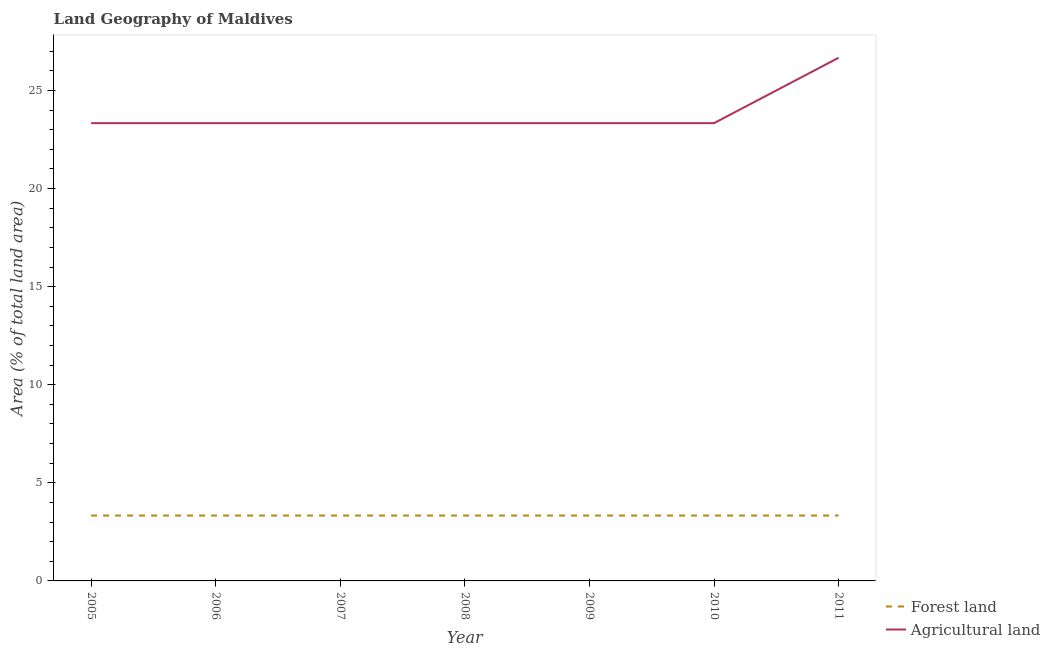How many different coloured lines are there?
Your answer should be compact. 2. Does the line corresponding to percentage of land area under forests intersect with the line corresponding to percentage of land area under agriculture?
Provide a short and direct response. No. What is the percentage of land area under forests in 2005?
Ensure brevity in your answer.  3.33. Across all years, what is the maximum percentage of land area under agriculture?
Offer a very short reply. 26.67. Across all years, what is the minimum percentage of land area under forests?
Offer a very short reply. 3.33. In which year was the percentage of land area under agriculture maximum?
Give a very brief answer. 2011. In which year was the percentage of land area under agriculture minimum?
Your answer should be compact. 2005. What is the total percentage of land area under forests in the graph?
Provide a succinct answer. 23.33. What is the difference between the percentage of land area under agriculture in 2005 and that in 2009?
Provide a succinct answer. 0. What is the difference between the percentage of land area under agriculture in 2009 and the percentage of land area under forests in 2008?
Give a very brief answer. 20. What is the average percentage of land area under agriculture per year?
Provide a short and direct response. 23.81. In the year 2005, what is the difference between the percentage of land area under forests and percentage of land area under agriculture?
Your answer should be compact. -20. What is the ratio of the percentage of land area under agriculture in 2005 to that in 2008?
Your answer should be very brief. 1. What is the difference between the highest and the second highest percentage of land area under forests?
Make the answer very short. 0. What is the difference between the highest and the lowest percentage of land area under agriculture?
Make the answer very short. 3.33. Is the sum of the percentage of land area under agriculture in 2009 and 2010 greater than the maximum percentage of land area under forests across all years?
Your answer should be compact. Yes. Does the percentage of land area under agriculture monotonically increase over the years?
Make the answer very short. No. Is the percentage of land area under agriculture strictly less than the percentage of land area under forests over the years?
Your answer should be very brief. No. How many years are there in the graph?
Offer a very short reply. 7. What is the difference between two consecutive major ticks on the Y-axis?
Your answer should be compact. 5. Are the values on the major ticks of Y-axis written in scientific E-notation?
Ensure brevity in your answer.  No. How many legend labels are there?
Keep it short and to the point. 2. How are the legend labels stacked?
Keep it short and to the point. Vertical. What is the title of the graph?
Provide a succinct answer. Land Geography of Maldives. What is the label or title of the X-axis?
Offer a terse response. Year. What is the label or title of the Y-axis?
Provide a short and direct response. Area (% of total land area). What is the Area (% of total land area) in Forest land in 2005?
Your answer should be compact. 3.33. What is the Area (% of total land area) of Agricultural land in 2005?
Make the answer very short. 23.33. What is the Area (% of total land area) in Forest land in 2006?
Make the answer very short. 3.33. What is the Area (% of total land area) of Agricultural land in 2006?
Offer a terse response. 23.33. What is the Area (% of total land area) of Forest land in 2007?
Make the answer very short. 3.33. What is the Area (% of total land area) in Agricultural land in 2007?
Provide a short and direct response. 23.33. What is the Area (% of total land area) of Forest land in 2008?
Ensure brevity in your answer.  3.33. What is the Area (% of total land area) in Agricultural land in 2008?
Offer a terse response. 23.33. What is the Area (% of total land area) of Forest land in 2009?
Make the answer very short. 3.33. What is the Area (% of total land area) of Agricultural land in 2009?
Offer a very short reply. 23.33. What is the Area (% of total land area) of Forest land in 2010?
Your answer should be very brief. 3.33. What is the Area (% of total land area) of Agricultural land in 2010?
Offer a very short reply. 23.33. What is the Area (% of total land area) in Forest land in 2011?
Keep it short and to the point. 3.33. What is the Area (% of total land area) in Agricultural land in 2011?
Your answer should be very brief. 26.67. Across all years, what is the maximum Area (% of total land area) in Forest land?
Give a very brief answer. 3.33. Across all years, what is the maximum Area (% of total land area) of Agricultural land?
Your response must be concise. 26.67. Across all years, what is the minimum Area (% of total land area) in Forest land?
Provide a succinct answer. 3.33. Across all years, what is the minimum Area (% of total land area) in Agricultural land?
Offer a terse response. 23.33. What is the total Area (% of total land area) of Forest land in the graph?
Offer a terse response. 23.33. What is the total Area (% of total land area) of Agricultural land in the graph?
Make the answer very short. 166.67. What is the difference between the Area (% of total land area) of Agricultural land in 2005 and that in 2006?
Offer a terse response. 0. What is the difference between the Area (% of total land area) of Agricultural land in 2005 and that in 2007?
Provide a short and direct response. 0. What is the difference between the Area (% of total land area) of Forest land in 2005 and that in 2008?
Offer a terse response. 0. What is the difference between the Area (% of total land area) of Agricultural land in 2005 and that in 2008?
Provide a short and direct response. 0. What is the difference between the Area (% of total land area) of Agricultural land in 2006 and that in 2007?
Keep it short and to the point. 0. What is the difference between the Area (% of total land area) in Forest land in 2006 and that in 2008?
Keep it short and to the point. 0. What is the difference between the Area (% of total land area) of Agricultural land in 2006 and that in 2008?
Your answer should be compact. 0. What is the difference between the Area (% of total land area) of Forest land in 2006 and that in 2011?
Ensure brevity in your answer.  0. What is the difference between the Area (% of total land area) in Agricultural land in 2006 and that in 2011?
Give a very brief answer. -3.33. What is the difference between the Area (% of total land area) in Forest land in 2007 and that in 2008?
Your response must be concise. 0. What is the difference between the Area (% of total land area) of Agricultural land in 2007 and that in 2008?
Offer a very short reply. 0. What is the difference between the Area (% of total land area) of Forest land in 2007 and that in 2009?
Ensure brevity in your answer.  0. What is the difference between the Area (% of total land area) of Agricultural land in 2007 and that in 2009?
Give a very brief answer. 0. What is the difference between the Area (% of total land area) of Forest land in 2007 and that in 2010?
Keep it short and to the point. 0. What is the difference between the Area (% of total land area) in Agricultural land in 2007 and that in 2010?
Provide a succinct answer. 0. What is the difference between the Area (% of total land area) in Forest land in 2007 and that in 2011?
Your answer should be very brief. 0. What is the difference between the Area (% of total land area) in Agricultural land in 2007 and that in 2011?
Provide a succinct answer. -3.33. What is the difference between the Area (% of total land area) of Forest land in 2008 and that in 2011?
Ensure brevity in your answer.  0. What is the difference between the Area (% of total land area) of Agricultural land in 2008 and that in 2011?
Ensure brevity in your answer.  -3.33. What is the difference between the Area (% of total land area) of Forest land in 2009 and that in 2010?
Provide a succinct answer. 0. What is the difference between the Area (% of total land area) in Agricultural land in 2009 and that in 2010?
Offer a very short reply. 0. What is the difference between the Area (% of total land area) of Forest land in 2010 and that in 2011?
Offer a terse response. 0. What is the difference between the Area (% of total land area) in Forest land in 2005 and the Area (% of total land area) in Agricultural land in 2008?
Ensure brevity in your answer.  -20. What is the difference between the Area (% of total land area) of Forest land in 2005 and the Area (% of total land area) of Agricultural land in 2009?
Give a very brief answer. -20. What is the difference between the Area (% of total land area) of Forest land in 2005 and the Area (% of total land area) of Agricultural land in 2011?
Give a very brief answer. -23.33. What is the difference between the Area (% of total land area) of Forest land in 2006 and the Area (% of total land area) of Agricultural land in 2010?
Provide a short and direct response. -20. What is the difference between the Area (% of total land area) of Forest land in 2006 and the Area (% of total land area) of Agricultural land in 2011?
Ensure brevity in your answer.  -23.33. What is the difference between the Area (% of total land area) of Forest land in 2007 and the Area (% of total land area) of Agricultural land in 2008?
Keep it short and to the point. -20. What is the difference between the Area (% of total land area) in Forest land in 2007 and the Area (% of total land area) in Agricultural land in 2009?
Keep it short and to the point. -20. What is the difference between the Area (% of total land area) in Forest land in 2007 and the Area (% of total land area) in Agricultural land in 2010?
Offer a very short reply. -20. What is the difference between the Area (% of total land area) in Forest land in 2007 and the Area (% of total land area) in Agricultural land in 2011?
Ensure brevity in your answer.  -23.33. What is the difference between the Area (% of total land area) in Forest land in 2008 and the Area (% of total land area) in Agricultural land in 2009?
Provide a short and direct response. -20. What is the difference between the Area (% of total land area) of Forest land in 2008 and the Area (% of total land area) of Agricultural land in 2010?
Offer a terse response. -20. What is the difference between the Area (% of total land area) in Forest land in 2008 and the Area (% of total land area) in Agricultural land in 2011?
Your response must be concise. -23.33. What is the difference between the Area (% of total land area) in Forest land in 2009 and the Area (% of total land area) in Agricultural land in 2010?
Provide a succinct answer. -20. What is the difference between the Area (% of total land area) in Forest land in 2009 and the Area (% of total land area) in Agricultural land in 2011?
Make the answer very short. -23.33. What is the difference between the Area (% of total land area) of Forest land in 2010 and the Area (% of total land area) of Agricultural land in 2011?
Provide a succinct answer. -23.33. What is the average Area (% of total land area) of Forest land per year?
Your answer should be compact. 3.33. What is the average Area (% of total land area) in Agricultural land per year?
Offer a terse response. 23.81. In the year 2006, what is the difference between the Area (% of total land area) of Forest land and Area (% of total land area) of Agricultural land?
Keep it short and to the point. -20. In the year 2007, what is the difference between the Area (% of total land area) in Forest land and Area (% of total land area) in Agricultural land?
Make the answer very short. -20. In the year 2008, what is the difference between the Area (% of total land area) in Forest land and Area (% of total land area) in Agricultural land?
Offer a terse response. -20. In the year 2009, what is the difference between the Area (% of total land area) of Forest land and Area (% of total land area) of Agricultural land?
Offer a very short reply. -20. In the year 2010, what is the difference between the Area (% of total land area) of Forest land and Area (% of total land area) of Agricultural land?
Offer a terse response. -20. In the year 2011, what is the difference between the Area (% of total land area) of Forest land and Area (% of total land area) of Agricultural land?
Offer a terse response. -23.33. What is the ratio of the Area (% of total land area) of Forest land in 2005 to that in 2006?
Your answer should be compact. 1. What is the ratio of the Area (% of total land area) of Agricultural land in 2005 to that in 2006?
Make the answer very short. 1. What is the ratio of the Area (% of total land area) in Forest land in 2005 to that in 2007?
Make the answer very short. 1. What is the ratio of the Area (% of total land area) in Agricultural land in 2005 to that in 2007?
Ensure brevity in your answer.  1. What is the ratio of the Area (% of total land area) in Forest land in 2005 to that in 2008?
Give a very brief answer. 1. What is the ratio of the Area (% of total land area) of Agricultural land in 2005 to that in 2009?
Offer a terse response. 1. What is the ratio of the Area (% of total land area) in Forest land in 2005 to that in 2010?
Offer a very short reply. 1. What is the ratio of the Area (% of total land area) in Forest land in 2005 to that in 2011?
Provide a succinct answer. 1. What is the ratio of the Area (% of total land area) in Agricultural land in 2005 to that in 2011?
Provide a short and direct response. 0.88. What is the ratio of the Area (% of total land area) in Forest land in 2006 to that in 2007?
Keep it short and to the point. 1. What is the ratio of the Area (% of total land area) of Forest land in 2006 to that in 2008?
Ensure brevity in your answer.  1. What is the ratio of the Area (% of total land area) of Agricultural land in 2006 to that in 2008?
Offer a terse response. 1. What is the ratio of the Area (% of total land area) of Agricultural land in 2006 to that in 2009?
Offer a terse response. 1. What is the ratio of the Area (% of total land area) in Agricultural land in 2006 to that in 2010?
Your answer should be very brief. 1. What is the ratio of the Area (% of total land area) of Agricultural land in 2006 to that in 2011?
Ensure brevity in your answer.  0.88. What is the ratio of the Area (% of total land area) of Agricultural land in 2007 to that in 2008?
Your answer should be compact. 1. What is the ratio of the Area (% of total land area) in Forest land in 2007 to that in 2009?
Ensure brevity in your answer.  1. What is the ratio of the Area (% of total land area) of Forest land in 2007 to that in 2010?
Provide a succinct answer. 1. What is the ratio of the Area (% of total land area) in Agricultural land in 2007 to that in 2011?
Offer a terse response. 0.88. What is the ratio of the Area (% of total land area) of Forest land in 2008 to that in 2009?
Your response must be concise. 1. What is the ratio of the Area (% of total land area) of Forest land in 2008 to that in 2010?
Offer a terse response. 1. What is the ratio of the Area (% of total land area) in Forest land in 2008 to that in 2011?
Give a very brief answer. 1. What is the ratio of the Area (% of total land area) in Agricultural land in 2008 to that in 2011?
Ensure brevity in your answer.  0.88. What is the ratio of the Area (% of total land area) in Forest land in 2009 to that in 2010?
Offer a very short reply. 1. What is the ratio of the Area (% of total land area) of Forest land in 2009 to that in 2011?
Make the answer very short. 1. What is the ratio of the Area (% of total land area) in Forest land in 2010 to that in 2011?
Offer a terse response. 1. What is the ratio of the Area (% of total land area) of Agricultural land in 2010 to that in 2011?
Your answer should be compact. 0.88. What is the difference between the highest and the second highest Area (% of total land area) of Forest land?
Your response must be concise. 0. What is the difference between the highest and the lowest Area (% of total land area) of Forest land?
Provide a succinct answer. 0. What is the difference between the highest and the lowest Area (% of total land area) of Agricultural land?
Keep it short and to the point. 3.33. 